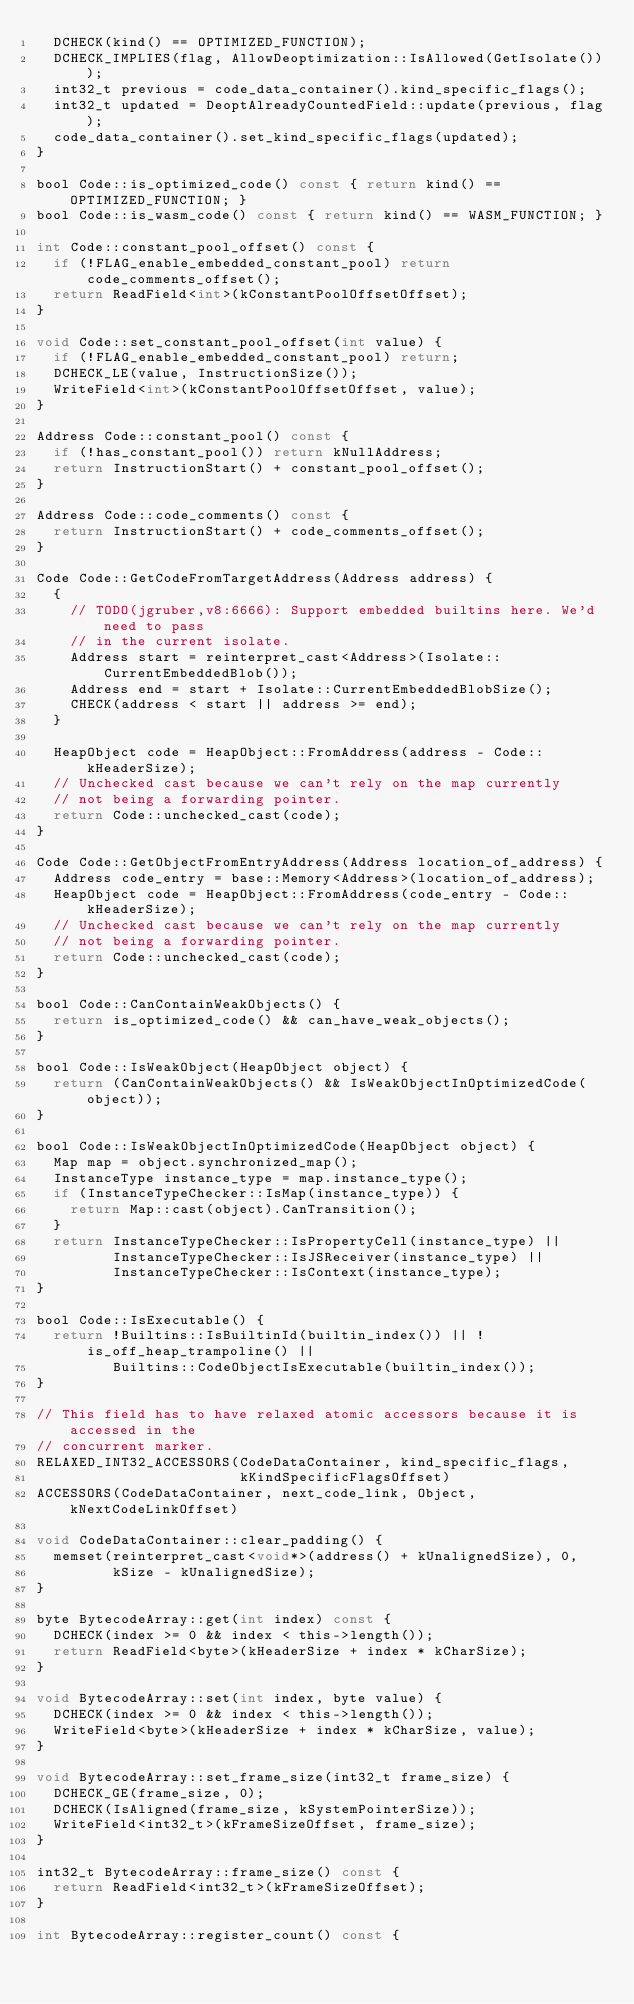<code> <loc_0><loc_0><loc_500><loc_500><_C_>  DCHECK(kind() == OPTIMIZED_FUNCTION);
  DCHECK_IMPLIES(flag, AllowDeoptimization::IsAllowed(GetIsolate()));
  int32_t previous = code_data_container().kind_specific_flags();
  int32_t updated = DeoptAlreadyCountedField::update(previous, flag);
  code_data_container().set_kind_specific_flags(updated);
}

bool Code::is_optimized_code() const { return kind() == OPTIMIZED_FUNCTION; }
bool Code::is_wasm_code() const { return kind() == WASM_FUNCTION; }

int Code::constant_pool_offset() const {
  if (!FLAG_enable_embedded_constant_pool) return code_comments_offset();
  return ReadField<int>(kConstantPoolOffsetOffset);
}

void Code::set_constant_pool_offset(int value) {
  if (!FLAG_enable_embedded_constant_pool) return;
  DCHECK_LE(value, InstructionSize());
  WriteField<int>(kConstantPoolOffsetOffset, value);
}

Address Code::constant_pool() const {
  if (!has_constant_pool()) return kNullAddress;
  return InstructionStart() + constant_pool_offset();
}

Address Code::code_comments() const {
  return InstructionStart() + code_comments_offset();
}

Code Code::GetCodeFromTargetAddress(Address address) {
  {
    // TODO(jgruber,v8:6666): Support embedded builtins here. We'd need to pass
    // in the current isolate.
    Address start = reinterpret_cast<Address>(Isolate::CurrentEmbeddedBlob());
    Address end = start + Isolate::CurrentEmbeddedBlobSize();
    CHECK(address < start || address >= end);
  }

  HeapObject code = HeapObject::FromAddress(address - Code::kHeaderSize);
  // Unchecked cast because we can't rely on the map currently
  // not being a forwarding pointer.
  return Code::unchecked_cast(code);
}

Code Code::GetObjectFromEntryAddress(Address location_of_address) {
  Address code_entry = base::Memory<Address>(location_of_address);
  HeapObject code = HeapObject::FromAddress(code_entry - Code::kHeaderSize);
  // Unchecked cast because we can't rely on the map currently
  // not being a forwarding pointer.
  return Code::unchecked_cast(code);
}

bool Code::CanContainWeakObjects() {
  return is_optimized_code() && can_have_weak_objects();
}

bool Code::IsWeakObject(HeapObject object) {
  return (CanContainWeakObjects() && IsWeakObjectInOptimizedCode(object));
}

bool Code::IsWeakObjectInOptimizedCode(HeapObject object) {
  Map map = object.synchronized_map();
  InstanceType instance_type = map.instance_type();
  if (InstanceTypeChecker::IsMap(instance_type)) {
    return Map::cast(object).CanTransition();
  }
  return InstanceTypeChecker::IsPropertyCell(instance_type) ||
         InstanceTypeChecker::IsJSReceiver(instance_type) ||
         InstanceTypeChecker::IsContext(instance_type);
}

bool Code::IsExecutable() {
  return !Builtins::IsBuiltinId(builtin_index()) || !is_off_heap_trampoline() ||
         Builtins::CodeObjectIsExecutable(builtin_index());
}

// This field has to have relaxed atomic accessors because it is accessed in the
// concurrent marker.
RELAXED_INT32_ACCESSORS(CodeDataContainer, kind_specific_flags,
                        kKindSpecificFlagsOffset)
ACCESSORS(CodeDataContainer, next_code_link, Object, kNextCodeLinkOffset)

void CodeDataContainer::clear_padding() {
  memset(reinterpret_cast<void*>(address() + kUnalignedSize), 0,
         kSize - kUnalignedSize);
}

byte BytecodeArray::get(int index) const {
  DCHECK(index >= 0 && index < this->length());
  return ReadField<byte>(kHeaderSize + index * kCharSize);
}

void BytecodeArray::set(int index, byte value) {
  DCHECK(index >= 0 && index < this->length());
  WriteField<byte>(kHeaderSize + index * kCharSize, value);
}

void BytecodeArray::set_frame_size(int32_t frame_size) {
  DCHECK_GE(frame_size, 0);
  DCHECK(IsAligned(frame_size, kSystemPointerSize));
  WriteField<int32_t>(kFrameSizeOffset, frame_size);
}

int32_t BytecodeArray::frame_size() const {
  return ReadField<int32_t>(kFrameSizeOffset);
}

int BytecodeArray::register_count() const {</code> 